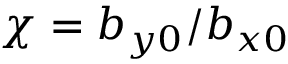Convert formula to latex. <formula><loc_0><loc_0><loc_500><loc_500>\chi = b _ { y 0 } / b _ { x 0 }</formula> 